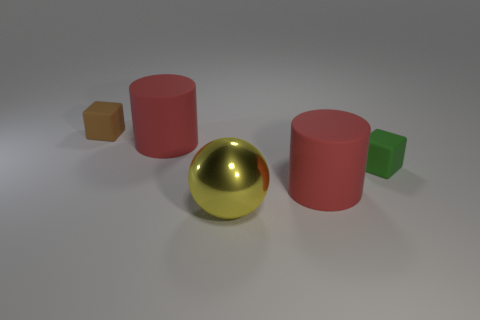There is a large cylinder that is in front of the green thing; is its color the same as the large matte cylinder that is left of the large yellow metallic object?
Your response must be concise. Yes. The metallic object is what color?
Offer a terse response. Yellow. What color is the cylinder that is behind the red rubber object in front of the tiny rubber thing that is in front of the brown matte cube?
Make the answer very short. Red. Is the material of the brown block the same as the yellow ball?
Your answer should be compact. No. How many yellow objects are either tiny blocks or big metallic objects?
Offer a very short reply. 1. There is a yellow sphere; how many yellow things are to the left of it?
Give a very brief answer. 0. Are there more green objects than small gray balls?
Your response must be concise. Yes. What shape is the red matte thing that is in front of the small rubber object on the right side of the brown thing?
Ensure brevity in your answer.  Cylinder. Is the number of big rubber cylinders on the left side of the green rubber thing greater than the number of small green matte things?
Provide a succinct answer. Yes. What number of brown objects are on the left side of the large object behind the green object?
Give a very brief answer. 1. 